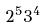Convert formula to latex. <formula><loc_0><loc_0><loc_500><loc_500>2 ^ { 5 } 3 ^ { 4 }</formula> 